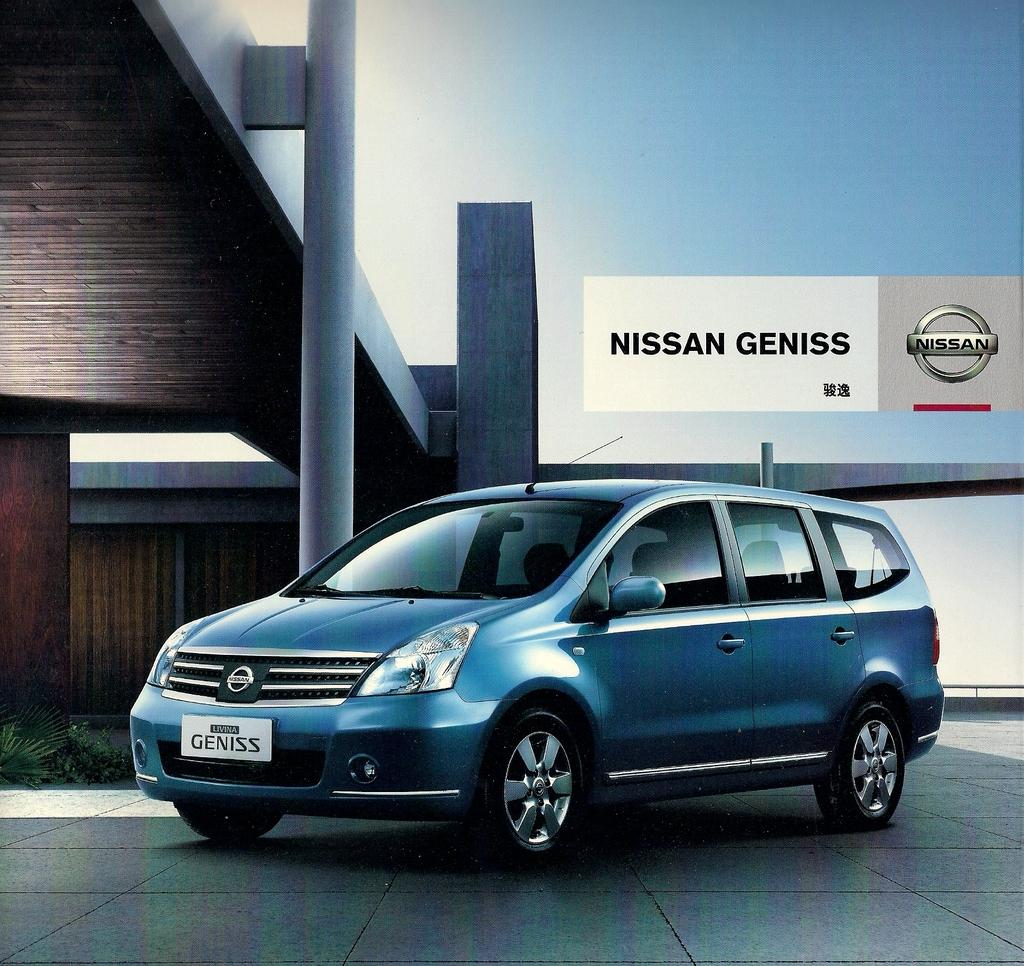<image>
Offer a succinct explanation of the picture presented. A blue Nissan Geniss is displayed in a showroom. 